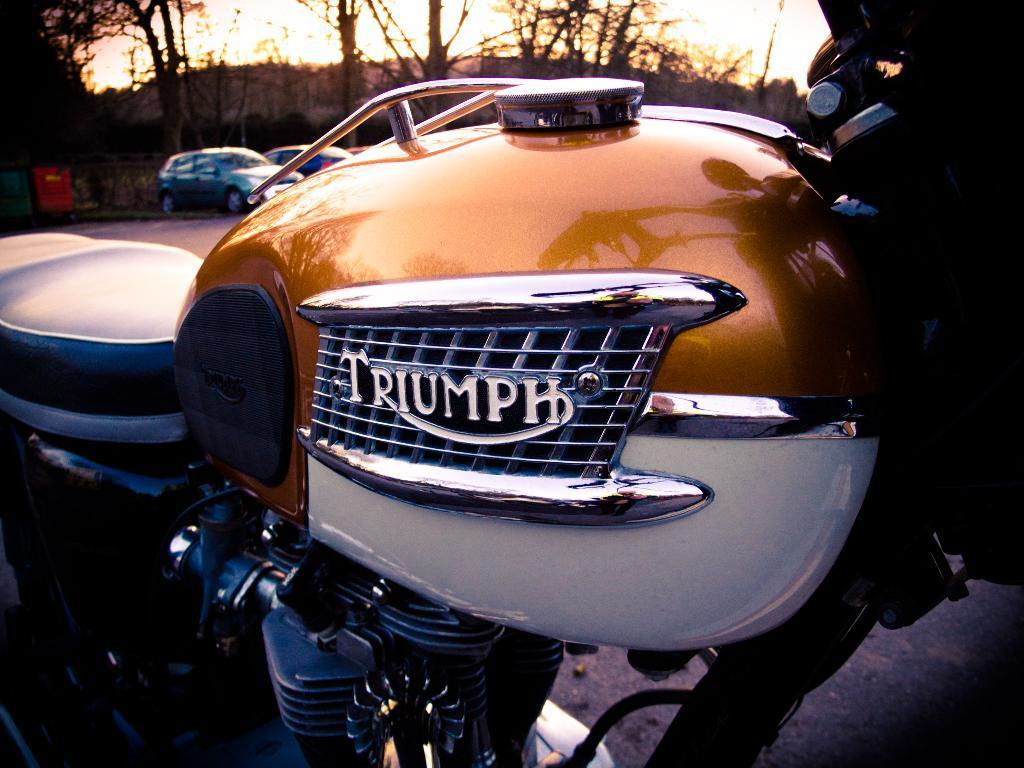Please provide a concise description of this image. In the foreground of this image, there is a truncated motor bike. In the background, there are two cars on the road, trees and the sky. 